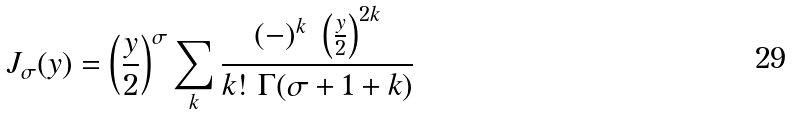Convert formula to latex. <formula><loc_0><loc_0><loc_500><loc_500>J _ { \sigma } ( y ) = \left ( \frac { y } { 2 } \right ) ^ { \sigma } \sum _ { k } \frac { ( - ) ^ { k } \ \left ( \frac { y } { 2 } \right ) ^ { 2 k } } { k ! \ \Gamma ( \sigma + 1 + k ) }</formula> 